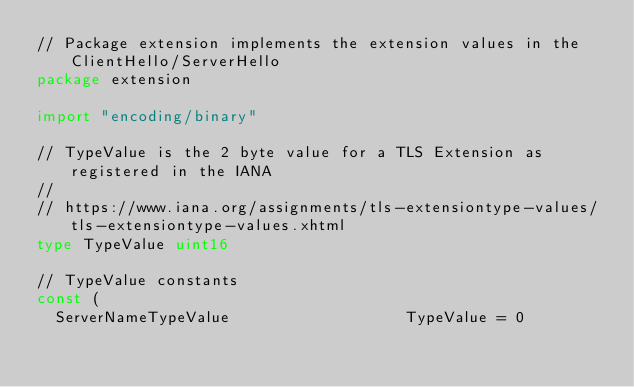Convert code to text. <code><loc_0><loc_0><loc_500><loc_500><_Go_>// Package extension implements the extension values in the ClientHello/ServerHello
package extension

import "encoding/binary"

// TypeValue is the 2 byte value for a TLS Extension as registered in the IANA
//
// https://www.iana.org/assignments/tls-extensiontype-values/tls-extensiontype-values.xhtml
type TypeValue uint16

// TypeValue constants
const (
	ServerNameTypeValue                   TypeValue = 0</code> 